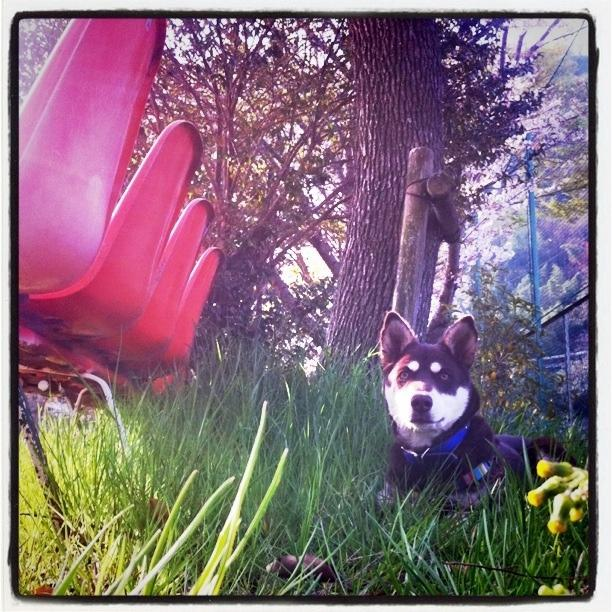What item is in the wrong setting? chairs 